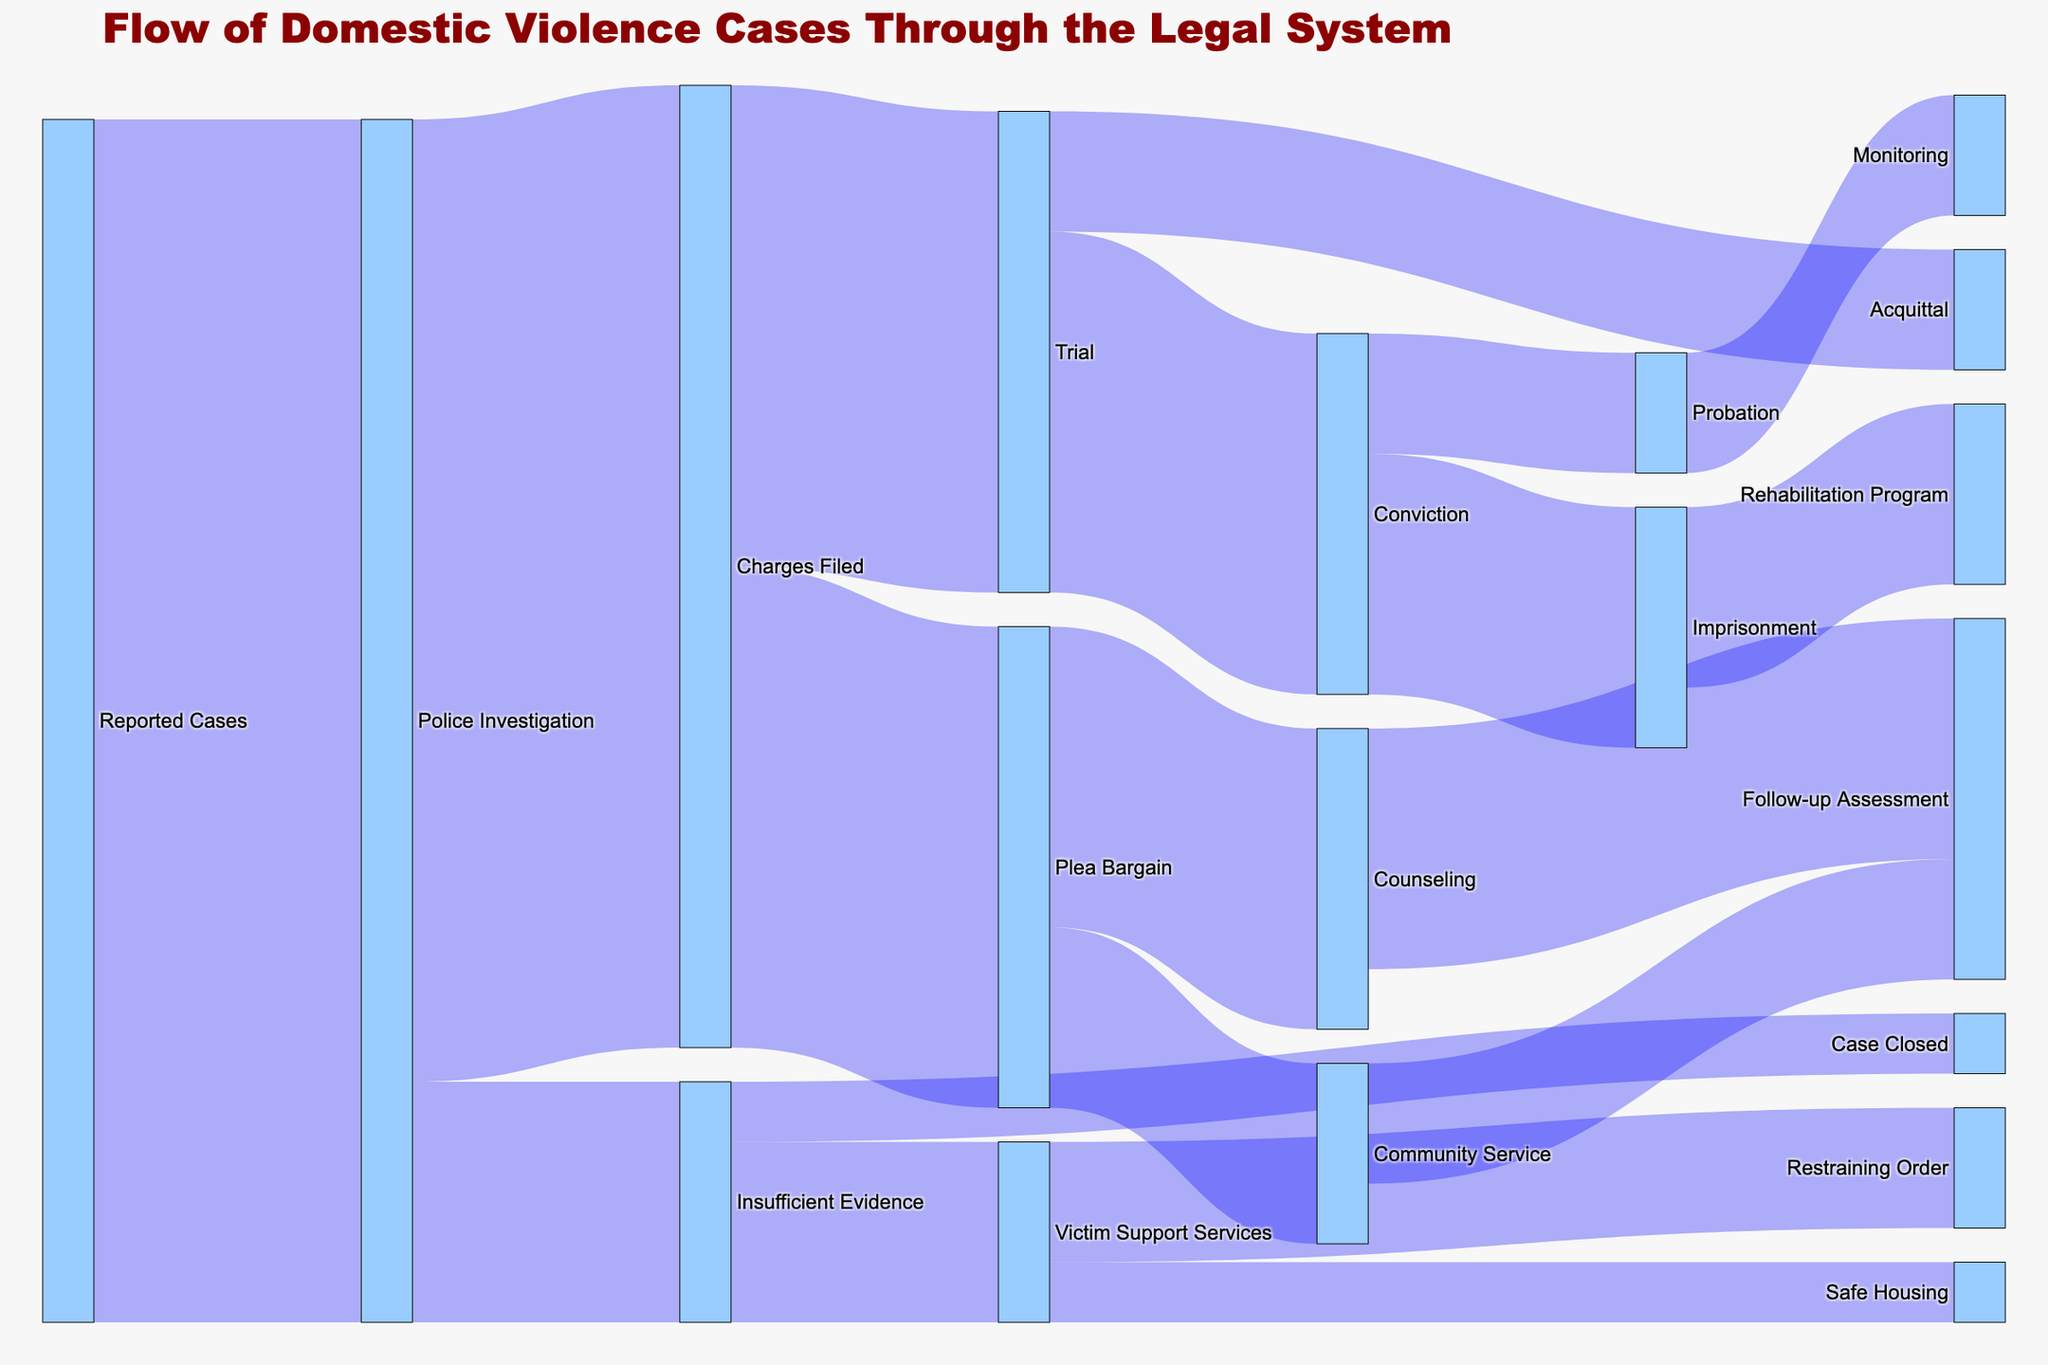What is the title of the Sankey diagram? The title of the Sankey diagram is typically displayed at the top of the figure and provides an overview of what the diagram represents. According to the provided code, the title for this diagram is "Flow of Domestic Violence Cases Through the Legal System."
Answer: Flow of Domestic Violence Cases Through the Legal System How many reported domestic violence cases proceed to police investigation? The initial flow of the diagram shows the transition from "Reported Cases" to "Police Investigation," with an associated value of 1000. This indicates the number of reported cases that proceed to police investigation.
Answer: 1000 How many cases end up with insufficient evidence during police investigation? The flow from "Police Investigation" to "Insufficient Evidence" shows a value of 200. This indicates the number of cases that are marked as having insufficient evidence.
Answer: 200 What is the total number of cases that result in conviction after trial? To find the total number of cases that result in conviction, we look at the flow from "Trial" heading towards "Conviction," which shows a value of 300.
Answer: 300 How many cases are closed due to insufficient evidence without any victim support services? To find this, we need to differentiate between two outcomes: "Victim Support Services" with a value of 150, and "Case Closed" with a value of 50. Only the cases without victim support services are closed.
Answer: 50 Which outcome has more cases after a plea bargain: community service or counseling? To find this, we compare the values of the flows from "Plea Bargain" to "Community Service" and "Counseling." "Community Service" has a value of 150, while "Counseling" has a value of 250.
Answer: Counseling How many cases result in probation following a conviction? The flow from "Conviction" to "Probation" shows a value of 100. This indicates the number of cases that result in probation.
Answer: 100 How many cases proceed to trial after charges are filed? The flow from "Charges Filed" to "Trial" shows a value of 400. This indicates the number of cases proceeding to trial.
Answer: 400 What is the color scheme used for nodes related to domestic violence, and why might this be significant? Nodes related to domestic violence cases are colored in '#FF9999', which is a shade of red. This color choice is likely significant as red is often associated with warning, danger, and urgency.
Answer: Red ('#FF9999') What proportion of convicted cases lead to imprisonment? We divide the value of cases leading to imprisonment by the total convicted cases. Flow to imprisonment has 200 cases, and total convictions are 300. Therefore, 200/300 = 0.67, which means 67%.
Answer: 67% 